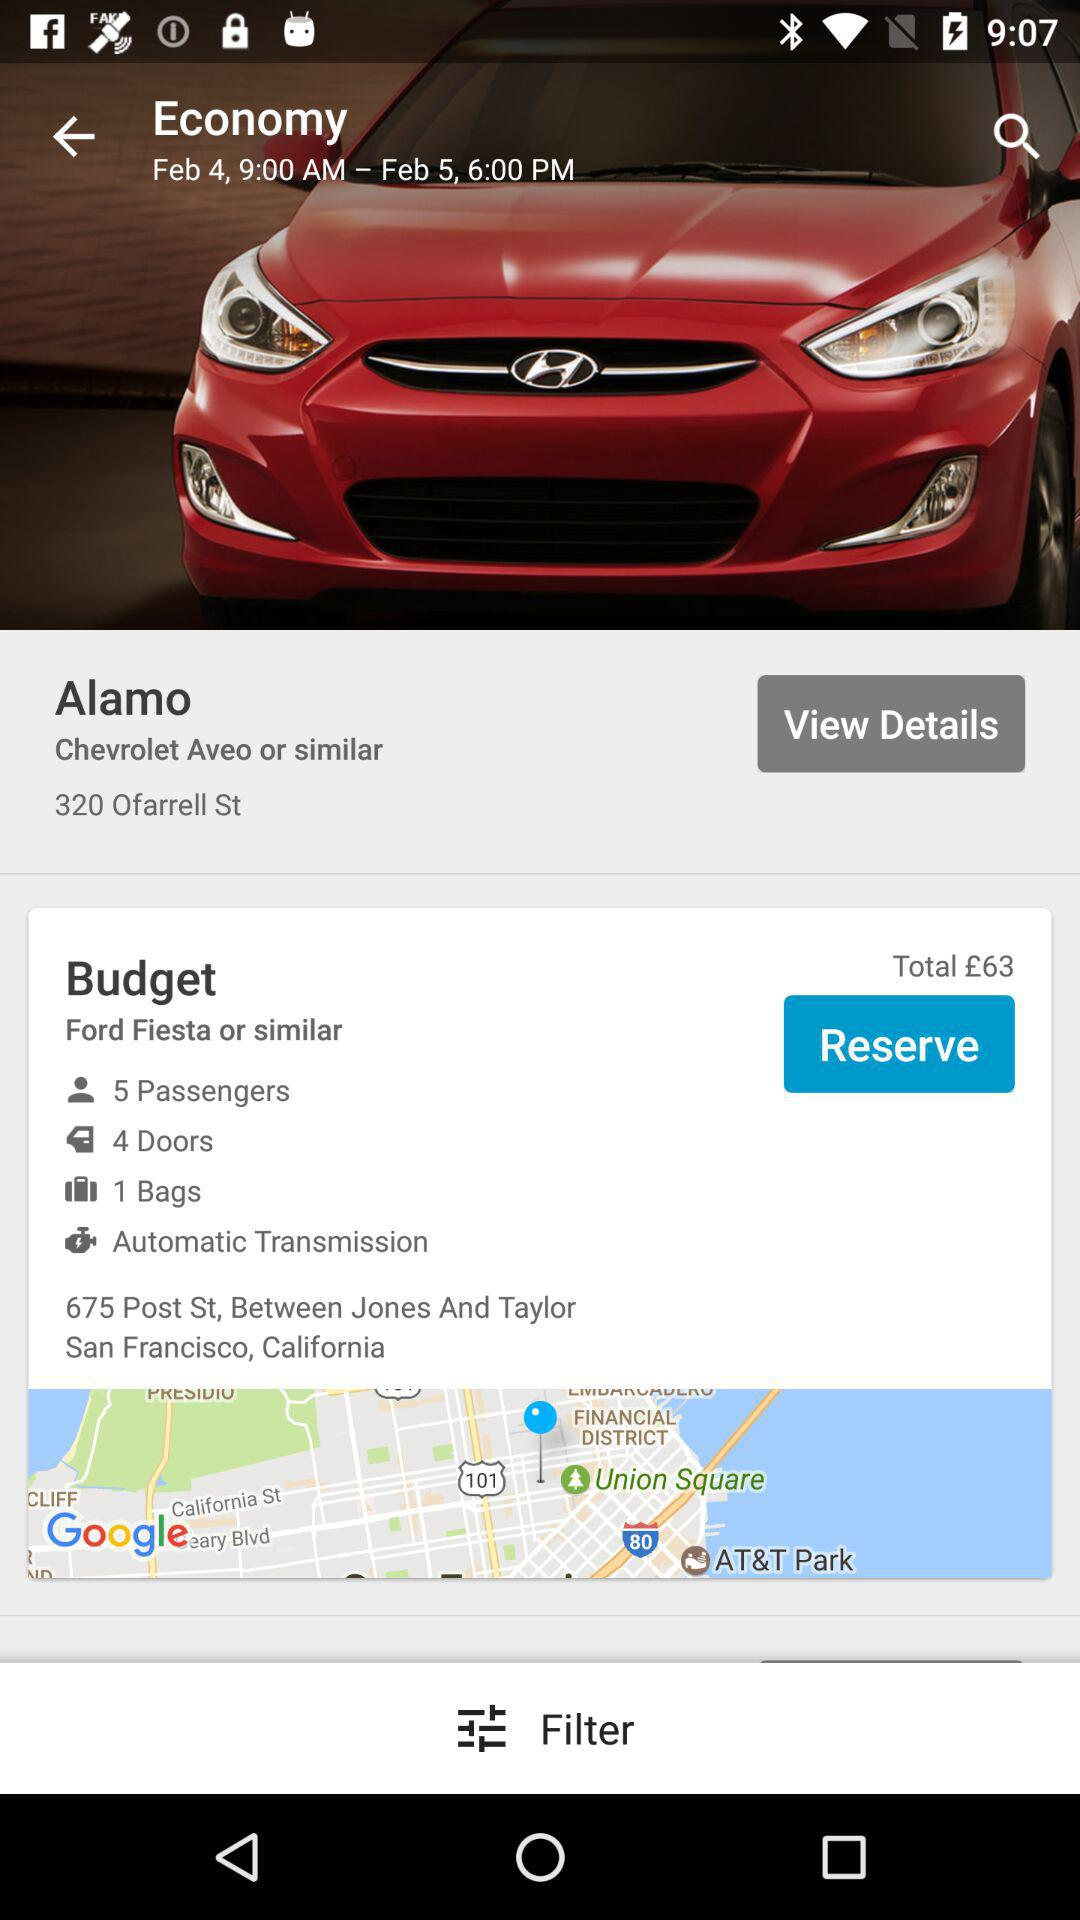How many passengers can sit in the car? The number of passengers who can sit in the car is 5. 